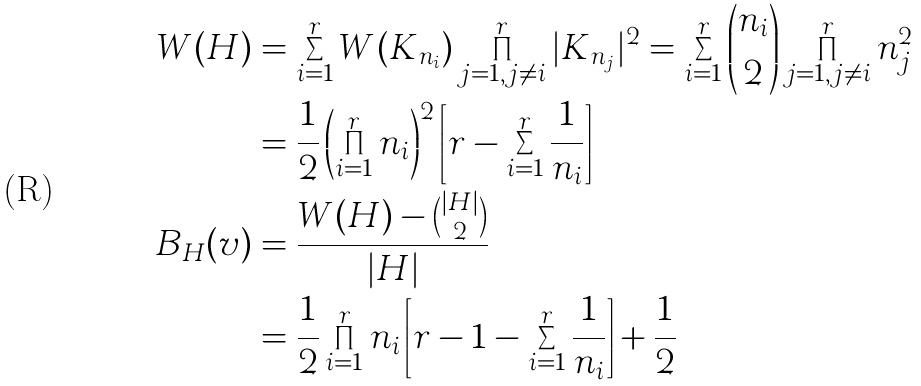Convert formula to latex. <formula><loc_0><loc_0><loc_500><loc_500>W ( H ) & = \sum _ { i = 1 } ^ { r } W ( K _ { n _ { i } } ) \prod _ { j = 1 , j \neq i } ^ { r } | K _ { n _ { j } } | ^ { 2 } = \sum _ { i = 1 } ^ { r } \binom { n _ { i } } { 2 } \prod _ { j = 1 , j \neq i } ^ { r } n _ { j } ^ { 2 } \\ & = \frac { 1 } { 2 } \left ( \prod _ { i = 1 } ^ { r } n _ { i } \right ) ^ { 2 } \left [ r - \sum _ { i = 1 } ^ { r } \frac { 1 } { n _ { i } } \right ] \\ B _ { H } ( v ) & = \frac { W ( H ) - \binom { | H | } { 2 } } { | H | } \\ & = \frac { 1 } { 2 } \prod _ { i = 1 } ^ { r } n _ { i } \left [ r - 1 - \sum _ { i = 1 } ^ { r } \frac { 1 } { n _ { i } } \right ] + \frac { 1 } { 2 }</formula> 